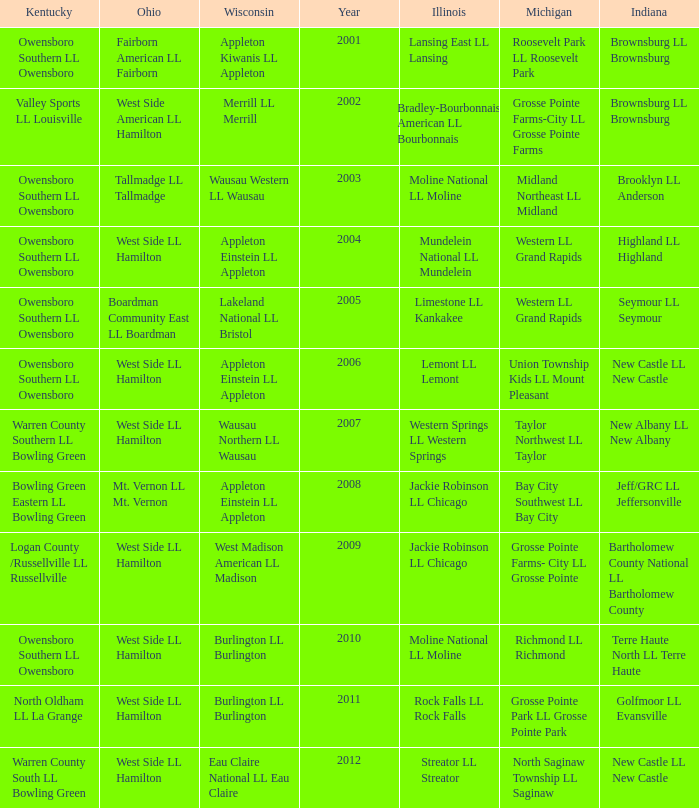What was the little league team from Kentucky when the little league team from Illinois was Rock Falls LL Rock Falls? North Oldham LL La Grange. 